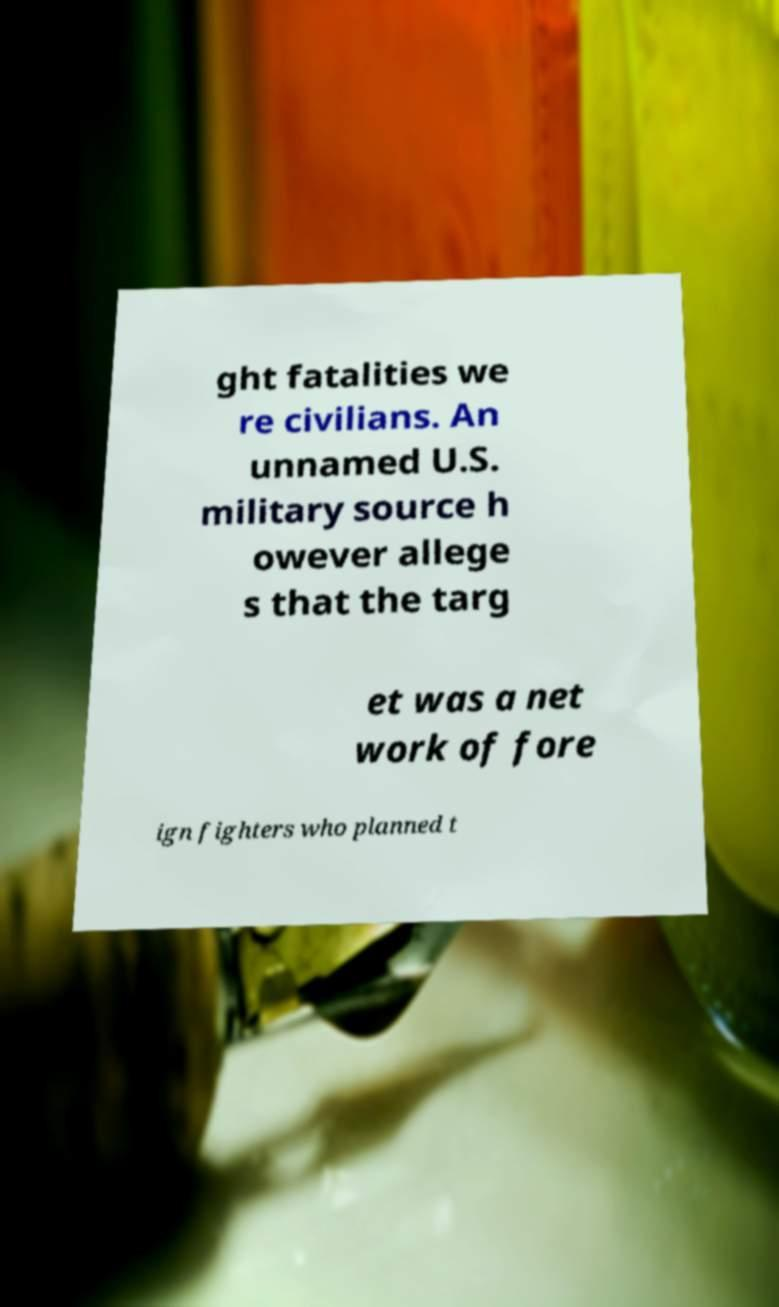Please identify and transcribe the text found in this image. ght fatalities we re civilians. An unnamed U.S. military source h owever allege s that the targ et was a net work of fore ign fighters who planned t 